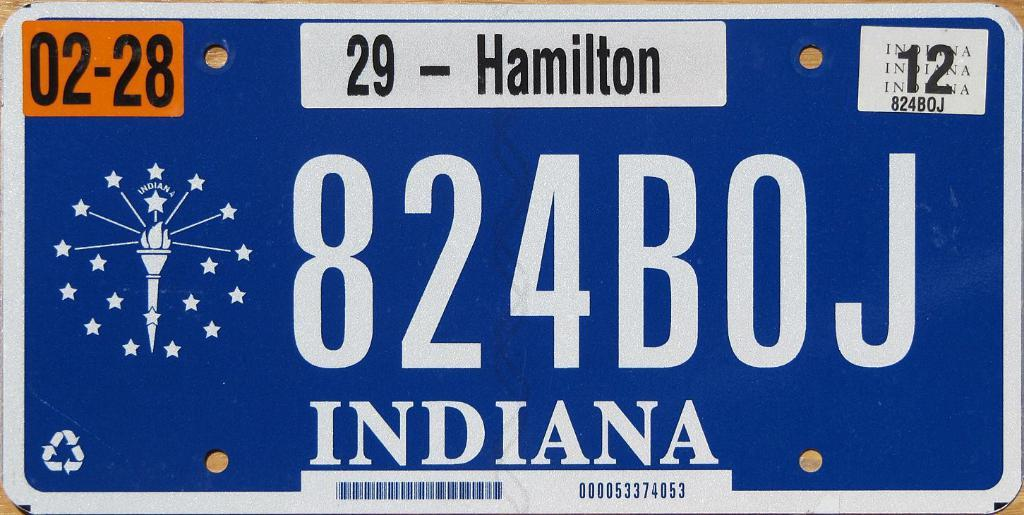<image>
Offer a succinct explanation of the picture presented. An Indiana license plate says 29 Hamilton at the top. 